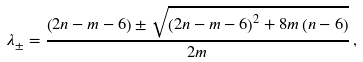<formula> <loc_0><loc_0><loc_500><loc_500>\lambda _ { \pm } = \frac { \left ( 2 n - m - 6 \right ) \pm \sqrt { \left ( 2 n - m - 6 \right ) ^ { 2 } + 8 m \left ( n - 6 \right ) } } { 2 m } \, ,</formula> 